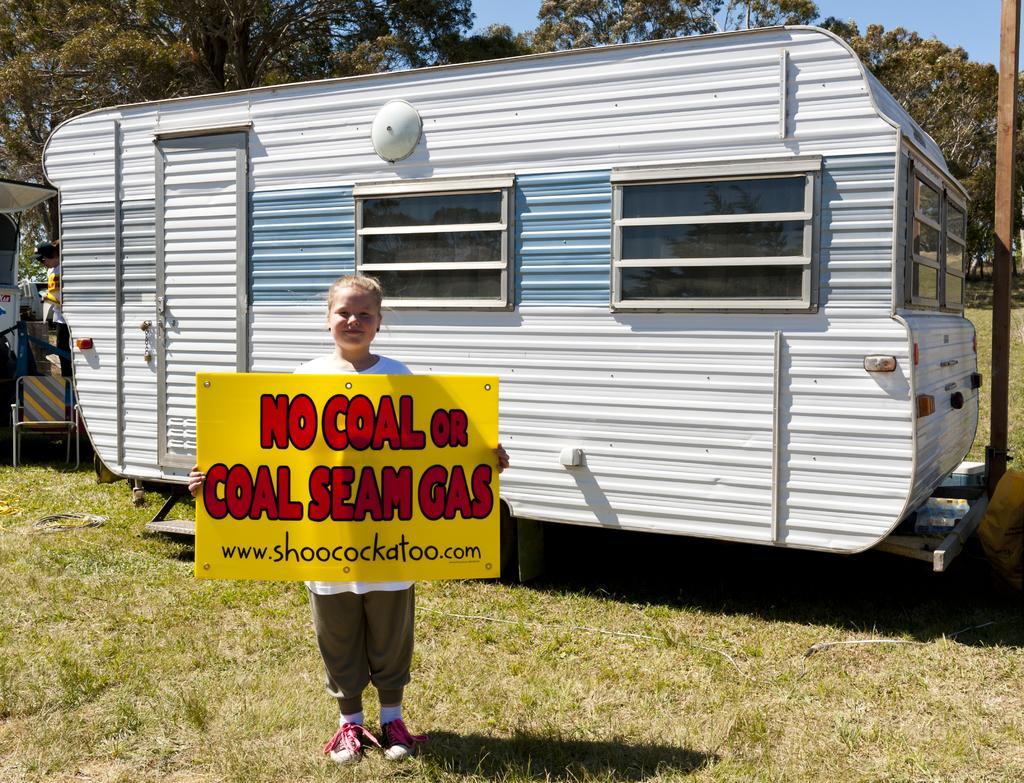How would you summarize this image in a sentence or two? A girl is standing by holding the placard. Behind her there is an iron vehicle, behind this there are trees. 